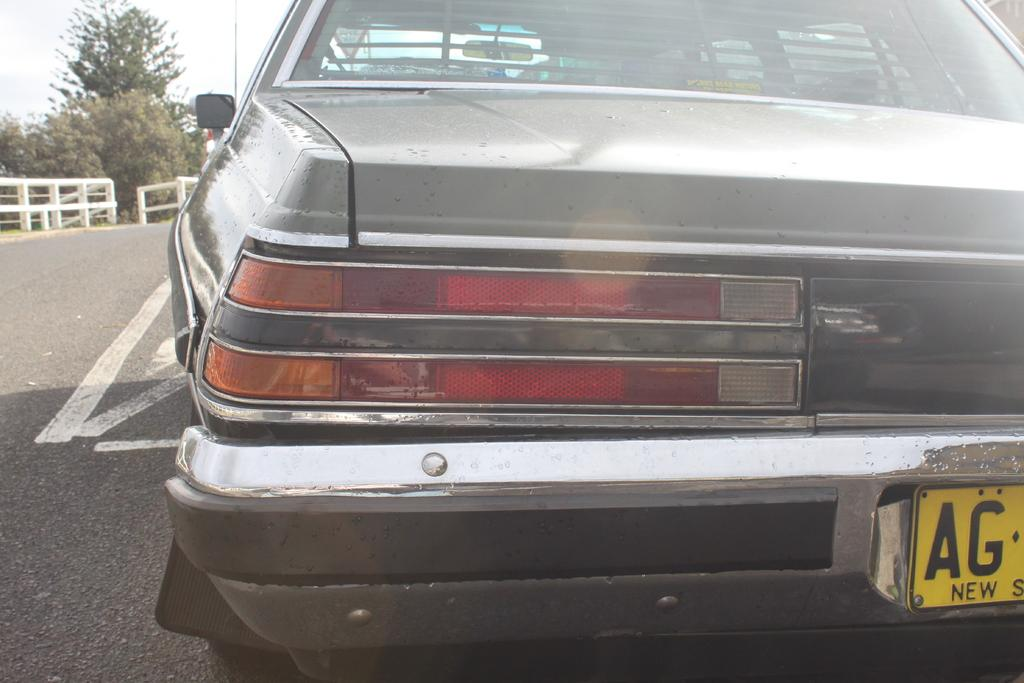What object is on the road in the image? There is a can on the road in the image. What type of natural elements can be seen in the image? There are trees in the image. What type of barrier is present in the image? There is fencing in the image. What is visible in the background of the image? The sky is visible in the image. What vertical structure can be seen in the image? There is a pole in the image. What time of day is depicted in the image? The time of day cannot be determined from the image, as there are no specific indicators of time. 